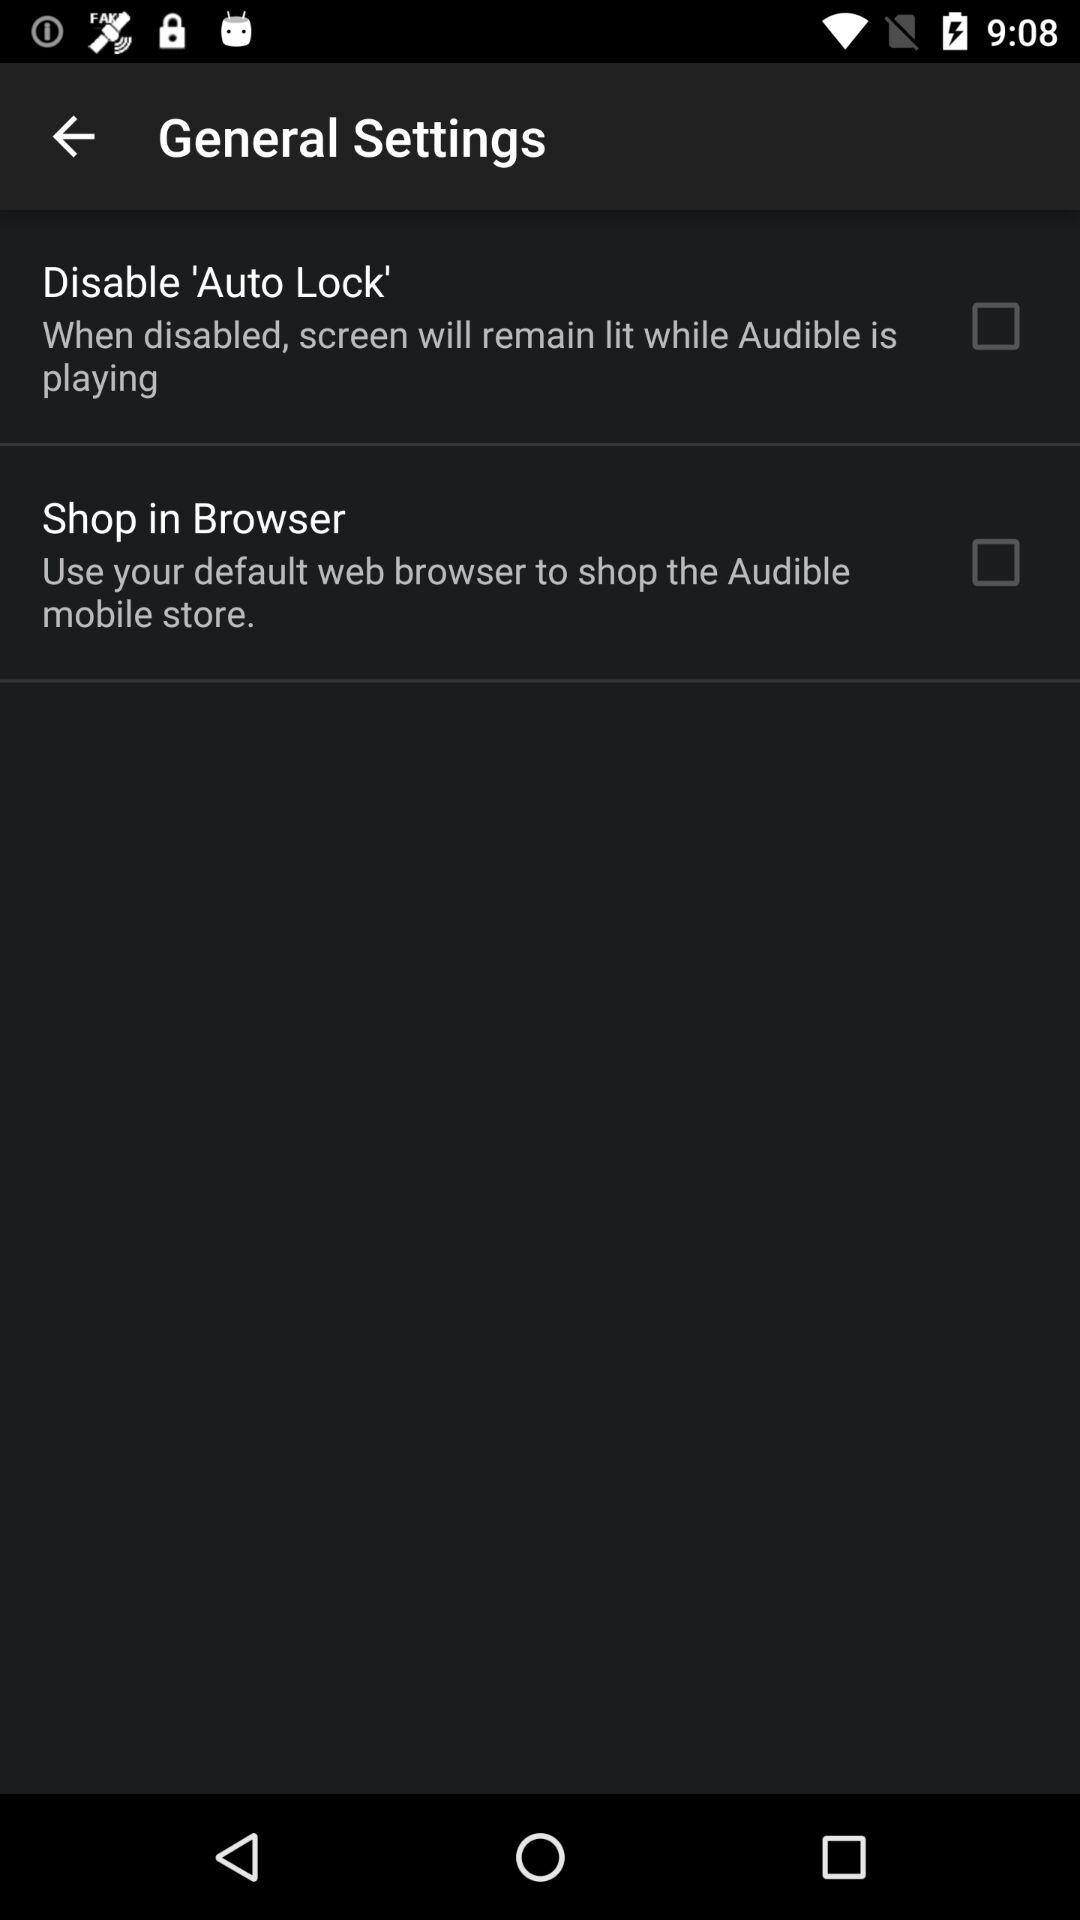What happens when we disable 'Auto Lock'? When you disable 'Auto Lock', the screen will remain lit while "Audible" is playing. 